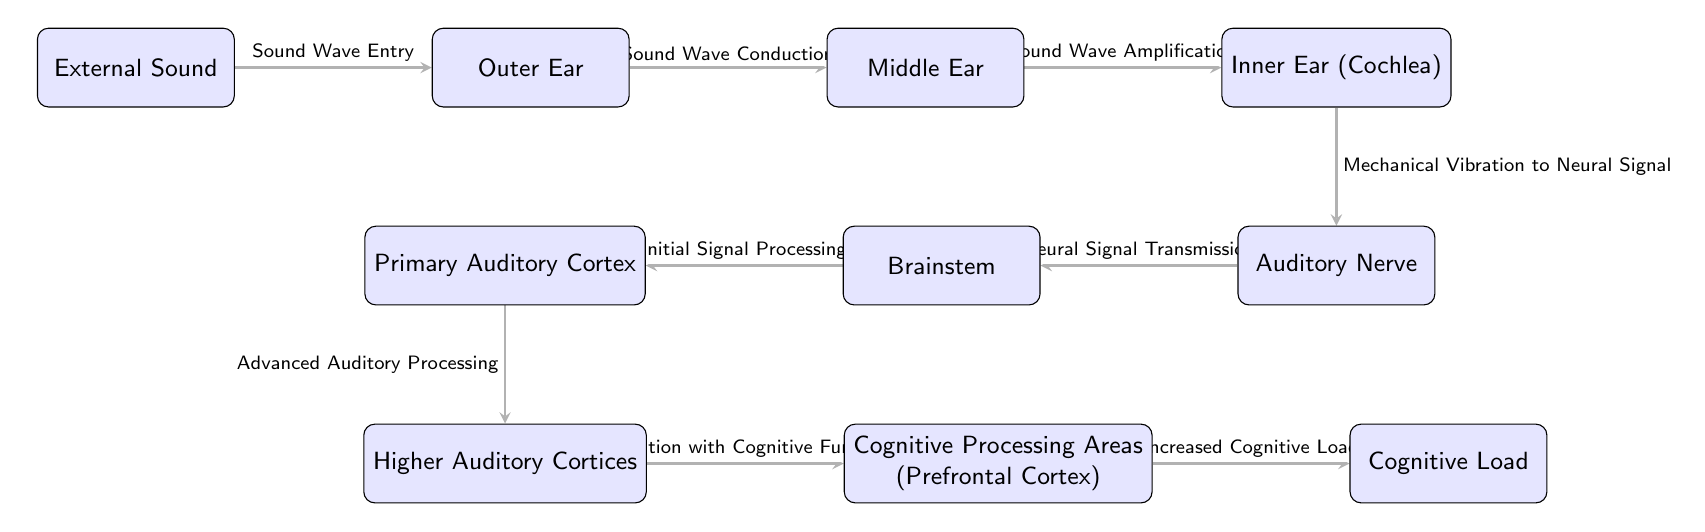What is the first step in the pathway of auditory signal processing? The first node in the diagram is "External Sound," indicating that this is the initial step in the auditory pathway.
Answer: External Sound How many nodes are present in the diagram? The diagram lists a total of ten distinct nodes related to auditory processing and cognitive load.
Answer: 10 Which node follows the "Inner Ear (Cochlea)" in the flow? After examining the flow, the node that directly follows "Inner Ear (Cochlea)" is "Auditory Nerve."
Answer: Auditory Nerve What type of processing occurs at the node labeled "Higher Auditory Cortices"? The connection leading to this node indicates that "Advanced Auditory Processing" occurs here as a result of the preceding signals.
Answer: Advanced Auditory Processing What is the connection between "Cognitive Processing Areas (Prefrontal Cortex)" and "Cognitive Load"? The arrow indicates that the relationship is one of influence, where "Cognitive Processing Areas (Prefrontal Cortex)" lead to an "Increased Cognitive Load."
Answer: Increased Cognitive Load What is the label associated with the transition from "Brainstem" to "Primary Auditory Cortex"? The connection shows that the transition is labeled as "Initial Signal Processing," indicating the processing task performed at this stage.
Answer: Initial Signal Processing How do "Higher Auditory Cortices" integrate with cognitive functions? The flow illustrates that "Higher Auditory Cortices" link to "Cognitive Processing Areas (Prefrontal Cortex)," indicating that auditory information is integrated into cognitive functions at this stage.
Answer: Integration with Cognitive Functions What signal is transmitted from "Auditory Nerve" to "Brainstem"? The description between these two nodes specifies that this transition involves "Neural Signal Transmission," clarifying the nature of the signal being processed.
Answer: Neural Signal Transmission What is the significance of the flow from "Outer Ear" to "Middle Ear"? The flow marked as "Sound Wave Conduction" signifies that this step is crucial for the transmission of sound waves from the outer ear to the middle ear for further processing.
Answer: Sound Wave Conduction 